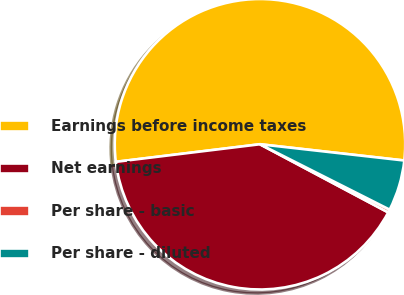Convert chart to OTSL. <chart><loc_0><loc_0><loc_500><loc_500><pie_chart><fcel>Earnings before income taxes<fcel>Net earnings<fcel>Per share - basic<fcel>Per share - diluted<nl><fcel>53.72%<fcel>40.29%<fcel>0.34%<fcel>5.65%<nl></chart> 